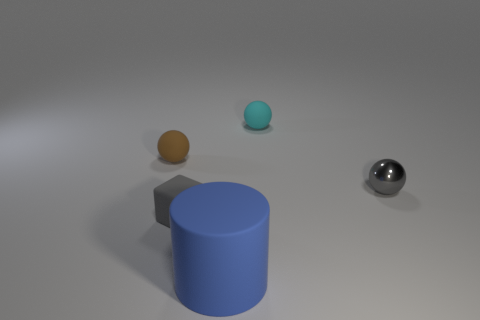The tiny block has what color?
Your answer should be very brief. Gray. Are there any matte things behind the gray rubber cube?
Ensure brevity in your answer.  Yes. Does the metallic ball have the same color as the block?
Offer a terse response. Yes. What number of tiny rubber things are the same color as the small metallic sphere?
Offer a terse response. 1. What size is the sphere to the left of the small rubber thing that is behind the brown rubber object?
Offer a terse response. Small. The small cyan thing is what shape?
Make the answer very short. Sphere. There is a small gray thing that is behind the gray matte thing; what material is it?
Your response must be concise. Metal. The small matte sphere on the right side of the gray thing that is in front of the tiny thing that is to the right of the cyan thing is what color?
Provide a succinct answer. Cyan. There is a block that is the same size as the gray metal object; what is its color?
Offer a terse response. Gray. How many matte things are large cylinders or tiny gray cubes?
Your response must be concise. 2. 